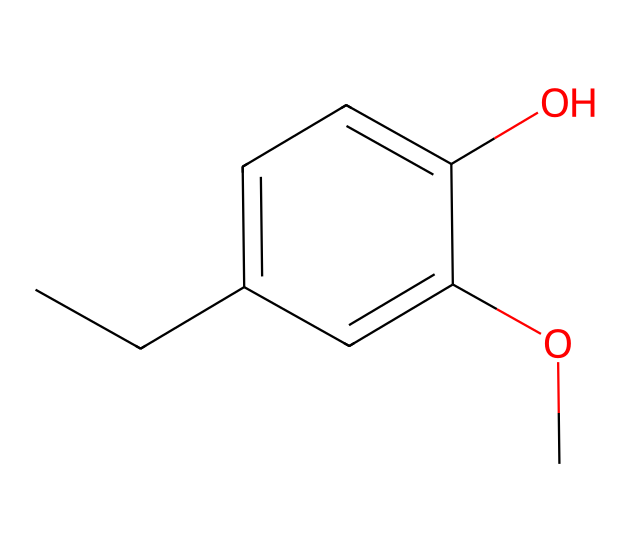What is the primary functional group in eugenol? The molecular structure shows a hydroxyl group (-OH) attached to a benzene ring, which characterizes it as a phenol.
Answer: hydroxyl group How many carbon atoms are in eugenol? By analyzing the SMILES notation, there are ten carbon atoms indicated, comprising both the side chain and the aromatic ring.
Answer: ten What is the molecular formula of eugenol? From the carbon and oxygen counts in the structure, eugenol has 10 carbons, 12 hydrogens, and 2 oxygens, giving the formula C10H12O2.
Answer: C10H12O2 Does eugenol have an ether group in its structure? The presence of an -OC- functional group in the structure indicates the existence of an ether group in addition to the phenolic component.
Answer: yes How does the -OH group affect the solubility of eugenol? The hydroxyl group increases solubility in water due to hydrogen bonding, making it more polar compared to compounds lacking this group.
Answer: increases What type of isomerism can eugenol exhibit due to its structure? Eugenol can exhibit cis-trans isomerism due to the presence of the double bond in the structure, which allows for different spatial arrangements.
Answer: cis-trans isomerism Is eugenol classified as a natural compound? Eugenol is derived from clove oil and is sourced from natural plants, classifying it as a natural compound found in essential oils.
Answer: yes 